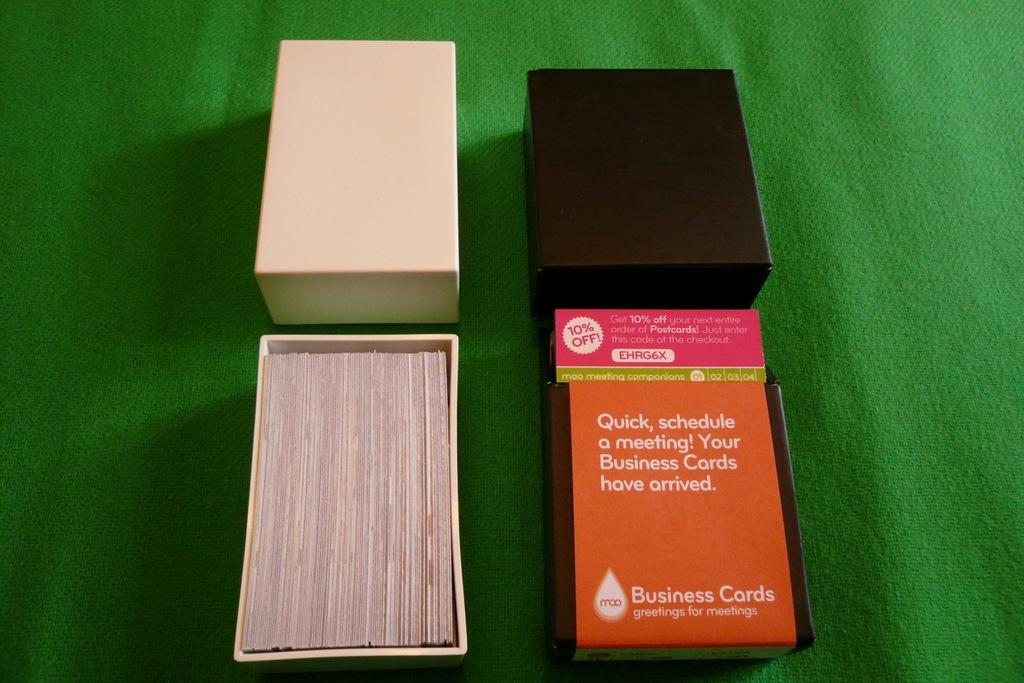What kind of cards are these?
Provide a succinct answer. Business cards. What do the cards suggest you do after opening them?
Give a very brief answer. Schedule a meeting. 